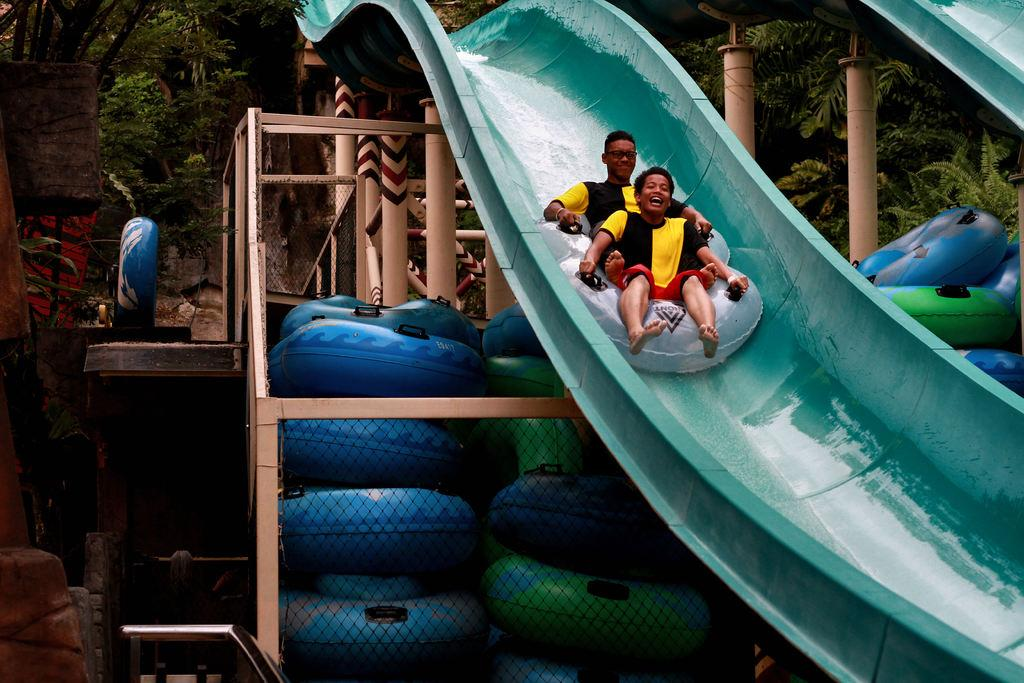What are the two people sitting on in the image? The two people are sitting on tubes in the image. What type of activity is depicted in the image? The image shows sliders, which suggests a water park or similar recreational area. What other objects can be seen in the image? There are poles, tubes, a mesh, and a rod visible in the image. What can be seen in the background of the image? There are trees in the background of the image. What type of wall can be seen in the image? There is no wall present in the image; it features people sitting on tubes in a recreational area. How does the person sitting on the tube care for their neck in the image? There is no indication in the image that the person is caring for their neck or experiencing any discomfort. 